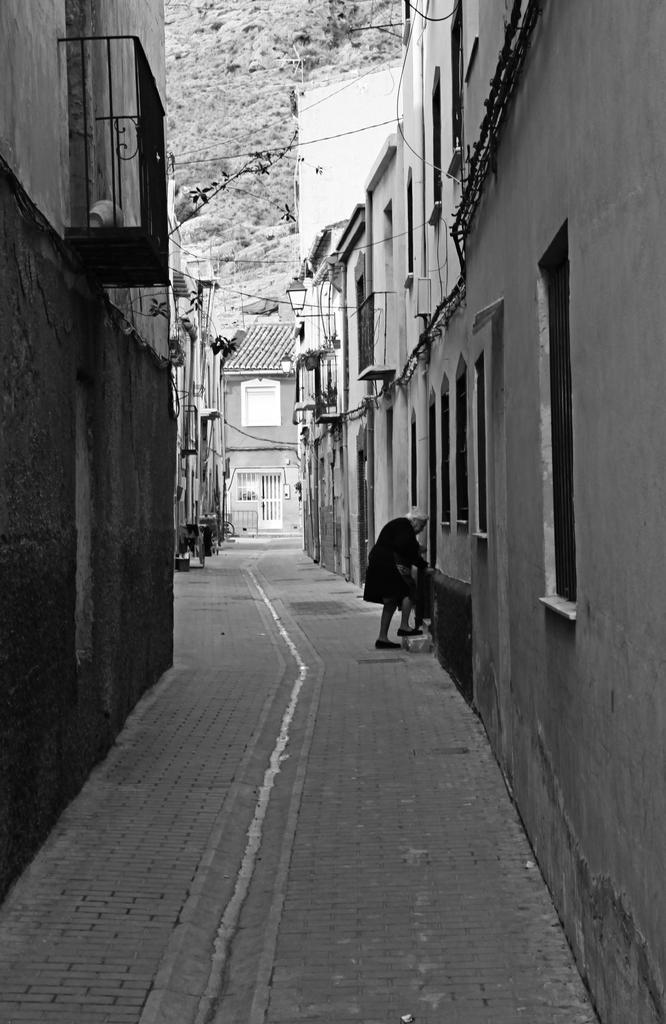Please provide a concise description of this image. In this black and white image, we can see a person in between buildings. There is a hill at the top of the image. 